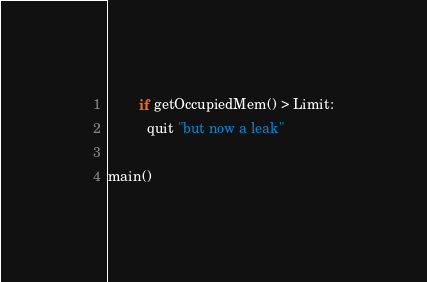Convert code to text. <code><loc_0><loc_0><loc_500><loc_500><_Nim_>        if getOccupiedMem() > Limit:
          quit "but now a leak"

main()
</code> 